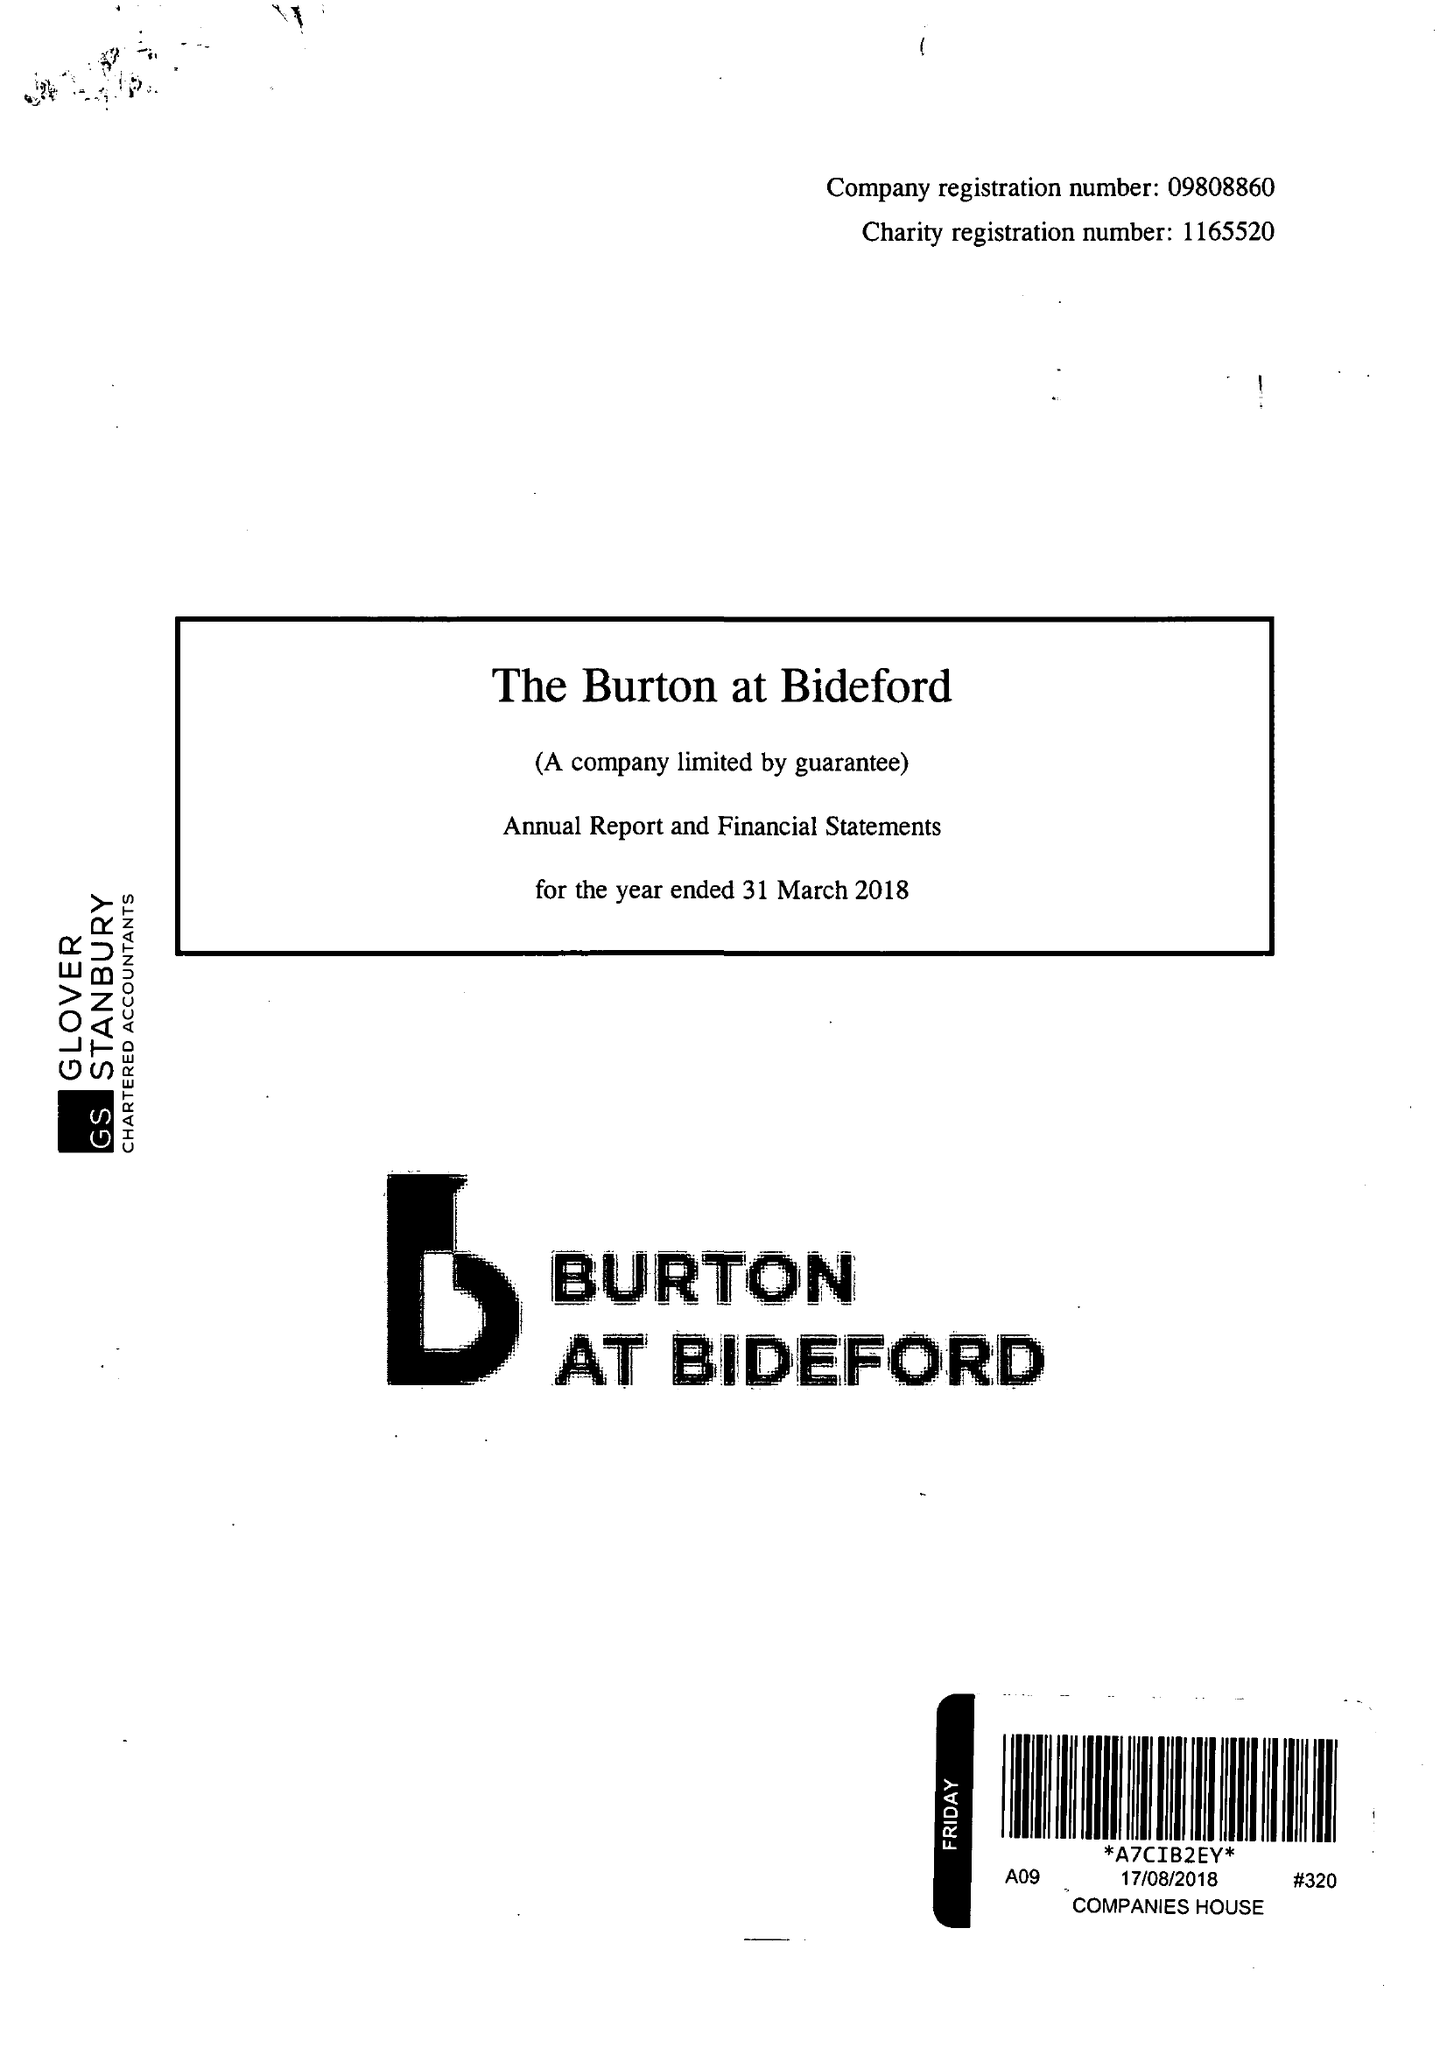What is the value for the address__postcode?
Answer the question using a single word or phrase. EX39 2QQ 